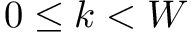Convert formula to latex. <formula><loc_0><loc_0><loc_500><loc_500>0 \leq k < W</formula> 